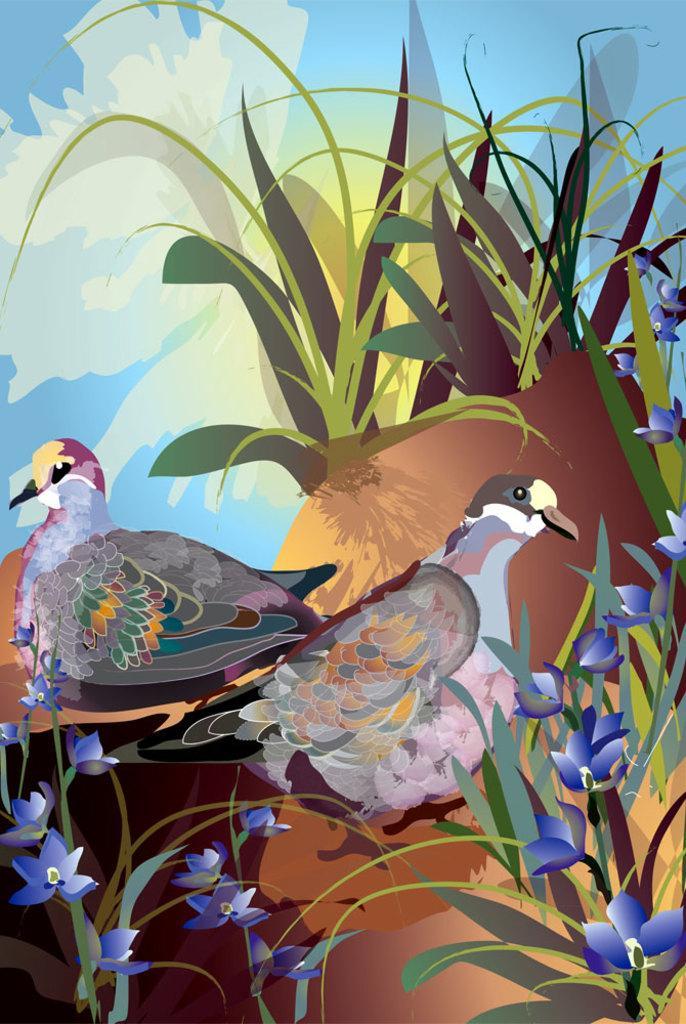Could you give a brief overview of what you see in this image? In this image I can see the digital art. I can see two birds which are orange, ash, white, black, pink and yellow in color and I can see few plants and few flowers which are blue in color. In the background I can see the sky. 